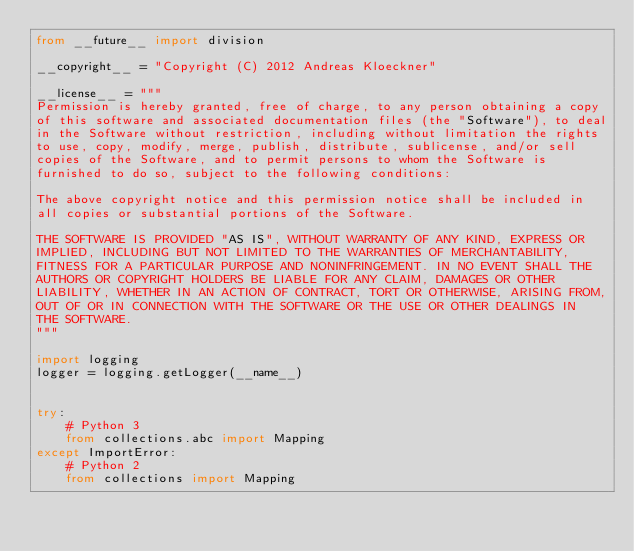<code> <loc_0><loc_0><loc_500><loc_500><_Python_>from __future__ import division

__copyright__ = "Copyright (C) 2012 Andreas Kloeckner"

__license__ = """
Permission is hereby granted, free of charge, to any person obtaining a copy
of this software and associated documentation files (the "Software"), to deal
in the Software without restriction, including without limitation the rights
to use, copy, modify, merge, publish, distribute, sublicense, and/or sell
copies of the Software, and to permit persons to whom the Software is
furnished to do so, subject to the following conditions:

The above copyright notice and this permission notice shall be included in
all copies or substantial portions of the Software.

THE SOFTWARE IS PROVIDED "AS IS", WITHOUT WARRANTY OF ANY KIND, EXPRESS OR
IMPLIED, INCLUDING BUT NOT LIMITED TO THE WARRANTIES OF MERCHANTABILITY,
FITNESS FOR A PARTICULAR PURPOSE AND NONINFRINGEMENT. IN NO EVENT SHALL THE
AUTHORS OR COPYRIGHT HOLDERS BE LIABLE FOR ANY CLAIM, DAMAGES OR OTHER
LIABILITY, WHETHER IN AN ACTION OF CONTRACT, TORT OR OTHERWISE, ARISING FROM,
OUT OF OR IN CONNECTION WITH THE SOFTWARE OR THE USE OR OTHER DEALINGS IN
THE SOFTWARE.
"""

import logging
logger = logging.getLogger(__name__)


try:
    # Python 3
    from collections.abc import Mapping
except ImportError:
    # Python 2
    from collections import Mapping

</code> 